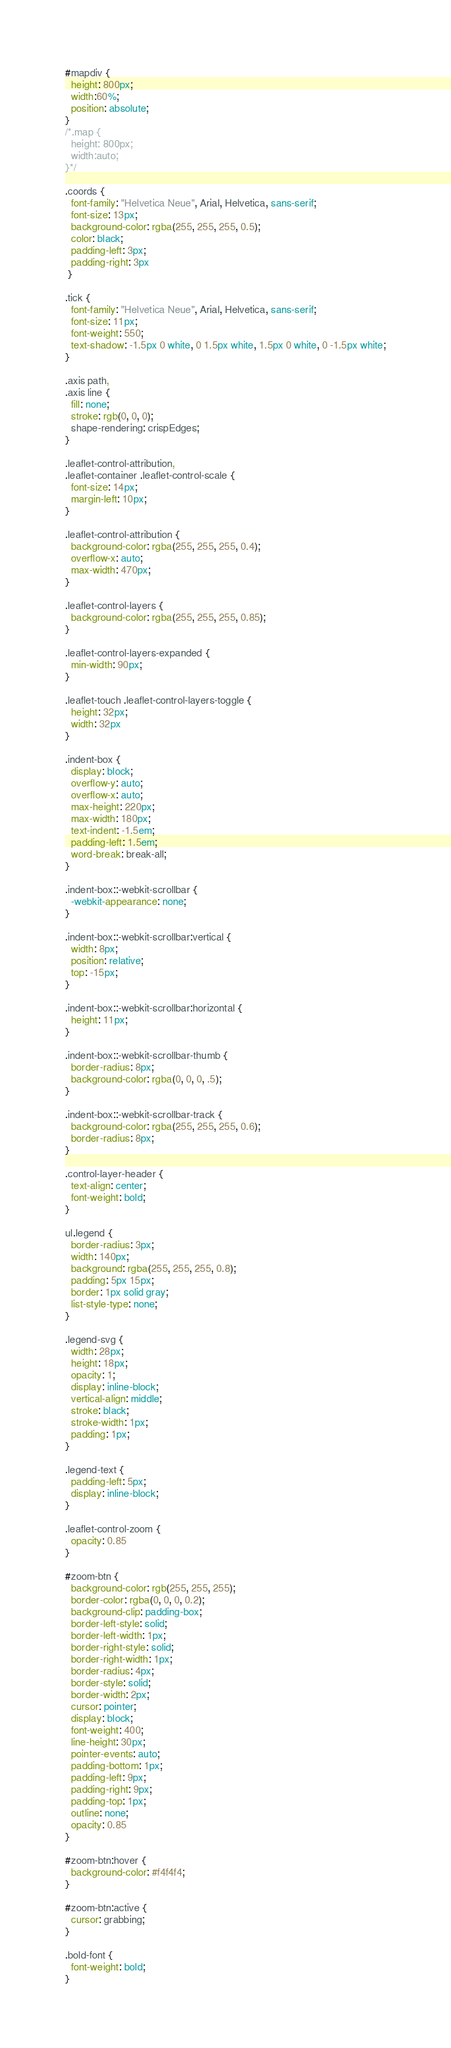Convert code to text. <code><loc_0><loc_0><loc_500><loc_500><_CSS_>#mapdiv {
  height: 800px;
  width:60%;
  position: absolute;
}
/*.map {
  height: 800px;
  width:auto;
}*/

.coords {
  font-family: "Helvetica Neue", Arial, Helvetica, sans-serif;
  font-size: 13px;
  background-color: rgba(255, 255, 255, 0.5);
  color: black;
  padding-left: 3px;
  padding-right: 3px
 }

.tick {
  font-family: "Helvetica Neue", Arial, Helvetica, sans-serif;
  font-size: 11px;
  font-weight: 550;
  text-shadow: -1.5px 0 white, 0 1.5px white, 1.5px 0 white, 0 -1.5px white;
}

.axis path,
.axis line {
  fill: none;
  stroke: rgb(0, 0, 0);
  shape-rendering: crispEdges;
}

.leaflet-control-attribution,
.leaflet-container .leaflet-control-scale {
  font-size: 14px;
  margin-left: 10px;
}

.leaflet-control-attribution {
  background-color: rgba(255, 255, 255, 0.4);
  overflow-x: auto;
  max-width: 470px;
}

.leaflet-control-layers {
  background-color: rgba(255, 255, 255, 0.85);
}

.leaflet-control-layers-expanded {
  min-width: 90px;
}

.leaflet-touch .leaflet-control-layers-toggle {
  height: 32px;
  width: 32px
}

.indent-box {
  display: block;
  overflow-y: auto;
  overflow-x: auto;
  max-height: 220px;
  max-width: 180px;
  text-indent: -1.5em;
  padding-left: 1.5em;
  word-break: break-all;
}

.indent-box::-webkit-scrollbar {
  -webkit-appearance: none;
}

.indent-box::-webkit-scrollbar:vertical {
  width: 8px;
  position: relative;
  top: -15px;
}

.indent-box::-webkit-scrollbar:horizontal {
  height: 11px;
}

.indent-box::-webkit-scrollbar-thumb {
  border-radius: 8px;
  background-color: rgba(0, 0, 0, .5);
}

.indent-box::-webkit-scrollbar-track {
  background-color: rgba(255, 255, 255, 0.6);
  border-radius: 8px;
}

.control-layer-header {
  text-align: center;
  font-weight: bold;
}

ul.legend {
  border-radius: 3px;
  width: 140px;
  background: rgba(255, 255, 255, 0.8);
  padding: 5px 15px;
  border: 1px solid gray;
  list-style-type: none;
}

.legend-svg {
  width: 28px;
  height: 18px;
  opacity: 1;
  display: inline-block;
  vertical-align: middle;
  stroke: black;
  stroke-width: 1px;
  padding: 1px;
}

.legend-text {
  padding-left: 5px;
  display: inline-block;
}

.leaflet-control-zoom {
  opacity: 0.85
}

#zoom-btn {
  background-color: rgb(255, 255, 255);
  border-color: rgba(0, 0, 0, 0.2);
  background-clip: padding-box;
  border-left-style: solid;
  border-left-width: 1px;
  border-right-style: solid;
  border-right-width: 1px;
  border-radius: 4px;
  border-style: solid;
  border-width: 2px;
  cursor: pointer;
  display: block;
  font-weight: 400;
  line-height: 30px;
  pointer-events: auto;
  padding-bottom: 1px;
  padding-left: 9px;
  padding-right: 9px;
  padding-top: 1px;
  outline: none;
  opacity: 0.85
}

#zoom-btn:hover {
  background-color: #f4f4f4;
}

#zoom-btn:active {
  cursor: grabbing;
}

.bold-font {
  font-weight: bold;
}
</code> 